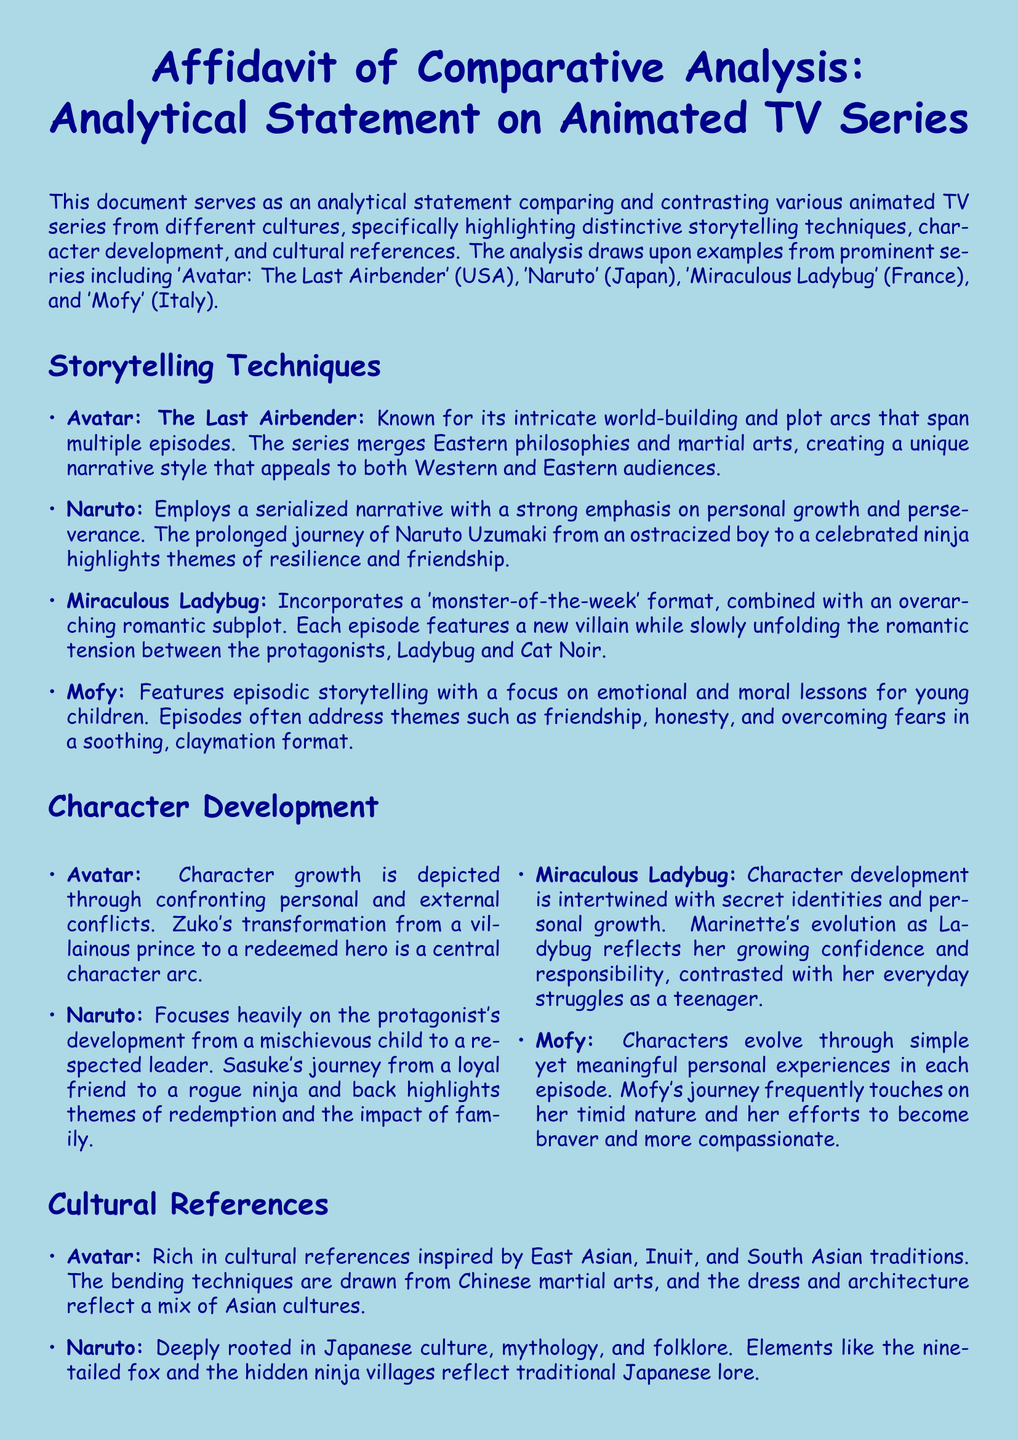What is the title of the document? The title is stated at the beginning of the document, outlining the focus on comparative analysis of animated TV series.
Answer: Affidavit of Comparative Analysis: Analytical Statement on Animated TV Series Which animated TV series is mentioned in relation to Italian culture? The document specifies this series as representing Italian storytelling traditions and experiences for children.
Answer: Mofy What narrative style is used in 'Avatar: The Last Airbender'? The document describes this style as intricate world-building with plot arcs spanning multiple episodes.
Answer: Intricate world-building Which character's transformation is central in 'Avatar: The Last Airbender'? The document highlights this character as undergoing significant growth from a villainous role to a heroic one.
Answer: Zuko What kind of storytelling does 'Mofy' feature? The document states that 'Mofy' is characterized by simple yet meaningful episodic storytelling aimed at young children.
Answer: Episodic storytelling In which city is 'Miraculous Ladybug' set? The document explicitly mentions this city as a significant backdrop for the events in the series, incorporating local culture.
Answer: Paris What theme is emphasized in 'Naruto' regarding its protagonist? The document notes that this theme revolves around the character's growth and development throughout the series.
Answer: Personal growth How are cultural references incorporated in 'Naruto'? The document mentions that these references are deeply rooted in specific elements of Japanese folklore and mythology.
Answer: Japanese culture What format does 'Miraculous Ladybug' use for its episodes? The document mentions this particular structure as combining episodic plots with ongoing storylines.
Answer: Monster-of-the-week format 